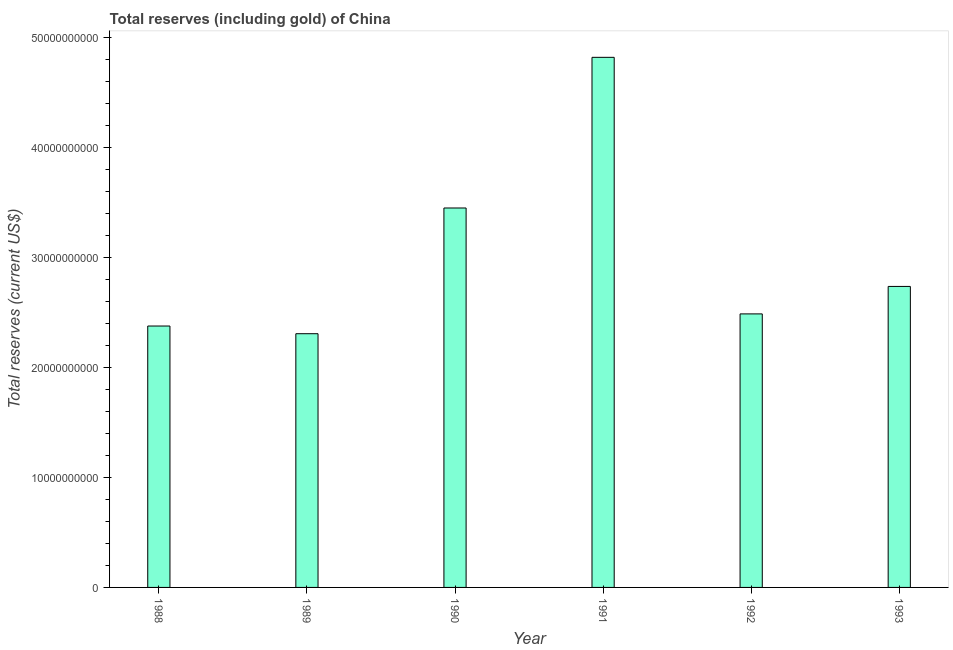Does the graph contain grids?
Your answer should be compact. No. What is the title of the graph?
Your answer should be very brief. Total reserves (including gold) of China. What is the label or title of the Y-axis?
Give a very brief answer. Total reserves (current US$). What is the total reserves (including gold) in 1990?
Your response must be concise. 3.45e+1. Across all years, what is the maximum total reserves (including gold)?
Provide a succinct answer. 4.82e+1. Across all years, what is the minimum total reserves (including gold)?
Give a very brief answer. 2.31e+1. In which year was the total reserves (including gold) maximum?
Make the answer very short. 1991. In which year was the total reserves (including gold) minimum?
Make the answer very short. 1989. What is the sum of the total reserves (including gold)?
Your answer should be very brief. 1.82e+11. What is the difference between the total reserves (including gold) in 1988 and 1990?
Provide a succinct answer. -1.07e+1. What is the average total reserves (including gold) per year?
Offer a terse response. 3.03e+1. What is the median total reserves (including gold)?
Ensure brevity in your answer.  2.61e+1. In how many years, is the total reserves (including gold) greater than 16000000000 US$?
Offer a terse response. 6. What is the ratio of the total reserves (including gold) in 1991 to that in 1992?
Provide a short and direct response. 1.94. Is the total reserves (including gold) in 1991 less than that in 1992?
Offer a terse response. No. What is the difference between the highest and the second highest total reserves (including gold)?
Your response must be concise. 1.37e+1. Is the sum of the total reserves (including gold) in 1990 and 1992 greater than the maximum total reserves (including gold) across all years?
Your answer should be very brief. Yes. What is the difference between the highest and the lowest total reserves (including gold)?
Provide a succinct answer. 2.51e+1. In how many years, is the total reserves (including gold) greater than the average total reserves (including gold) taken over all years?
Your response must be concise. 2. What is the Total reserves (current US$) in 1988?
Offer a very short reply. 2.38e+1. What is the Total reserves (current US$) in 1989?
Offer a terse response. 2.31e+1. What is the Total reserves (current US$) in 1990?
Offer a very short reply. 3.45e+1. What is the Total reserves (current US$) in 1991?
Keep it short and to the point. 4.82e+1. What is the Total reserves (current US$) in 1992?
Ensure brevity in your answer.  2.49e+1. What is the Total reserves (current US$) of 1993?
Give a very brief answer. 2.73e+1. What is the difference between the Total reserves (current US$) in 1988 and 1989?
Give a very brief answer. 6.99e+08. What is the difference between the Total reserves (current US$) in 1988 and 1990?
Make the answer very short. -1.07e+1. What is the difference between the Total reserves (current US$) in 1988 and 1991?
Ensure brevity in your answer.  -2.44e+1. What is the difference between the Total reserves (current US$) in 1988 and 1992?
Give a very brief answer. -1.10e+09. What is the difference between the Total reserves (current US$) in 1988 and 1993?
Offer a terse response. -3.60e+09. What is the difference between the Total reserves (current US$) in 1989 and 1990?
Provide a short and direct response. -1.14e+1. What is the difference between the Total reserves (current US$) in 1989 and 1991?
Make the answer very short. -2.51e+1. What is the difference between the Total reserves (current US$) in 1989 and 1992?
Offer a terse response. -1.80e+09. What is the difference between the Total reserves (current US$) in 1989 and 1993?
Provide a short and direct response. -4.30e+09. What is the difference between the Total reserves (current US$) in 1990 and 1991?
Your answer should be very brief. -1.37e+1. What is the difference between the Total reserves (current US$) in 1990 and 1992?
Your answer should be compact. 9.62e+09. What is the difference between the Total reserves (current US$) in 1990 and 1993?
Offer a terse response. 7.13e+09. What is the difference between the Total reserves (current US$) in 1991 and 1992?
Your answer should be compact. 2.33e+1. What is the difference between the Total reserves (current US$) in 1991 and 1993?
Provide a succinct answer. 2.08e+1. What is the difference between the Total reserves (current US$) in 1992 and 1993?
Ensure brevity in your answer.  -2.50e+09. What is the ratio of the Total reserves (current US$) in 1988 to that in 1990?
Provide a succinct answer. 0.69. What is the ratio of the Total reserves (current US$) in 1988 to that in 1991?
Make the answer very short. 0.49. What is the ratio of the Total reserves (current US$) in 1988 to that in 1992?
Offer a terse response. 0.96. What is the ratio of the Total reserves (current US$) in 1988 to that in 1993?
Provide a succinct answer. 0.87. What is the ratio of the Total reserves (current US$) in 1989 to that in 1990?
Provide a short and direct response. 0.67. What is the ratio of the Total reserves (current US$) in 1989 to that in 1991?
Your answer should be compact. 0.48. What is the ratio of the Total reserves (current US$) in 1989 to that in 1992?
Offer a terse response. 0.93. What is the ratio of the Total reserves (current US$) in 1989 to that in 1993?
Your response must be concise. 0.84. What is the ratio of the Total reserves (current US$) in 1990 to that in 1991?
Offer a terse response. 0.72. What is the ratio of the Total reserves (current US$) in 1990 to that in 1992?
Make the answer very short. 1.39. What is the ratio of the Total reserves (current US$) in 1990 to that in 1993?
Provide a short and direct response. 1.26. What is the ratio of the Total reserves (current US$) in 1991 to that in 1992?
Your response must be concise. 1.94. What is the ratio of the Total reserves (current US$) in 1991 to that in 1993?
Make the answer very short. 1.76. What is the ratio of the Total reserves (current US$) in 1992 to that in 1993?
Keep it short and to the point. 0.91. 